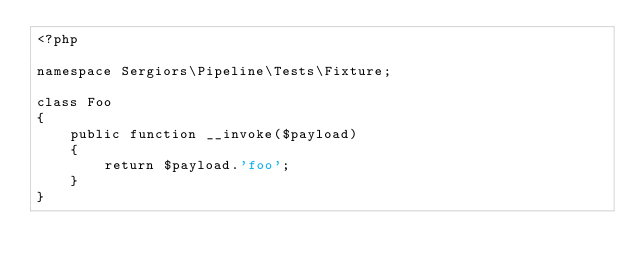<code> <loc_0><loc_0><loc_500><loc_500><_PHP_><?php

namespace Sergiors\Pipeline\Tests\Fixture;

class Foo
{
    public function __invoke($payload)
    {
        return $payload.'foo';
    }
}
</code> 